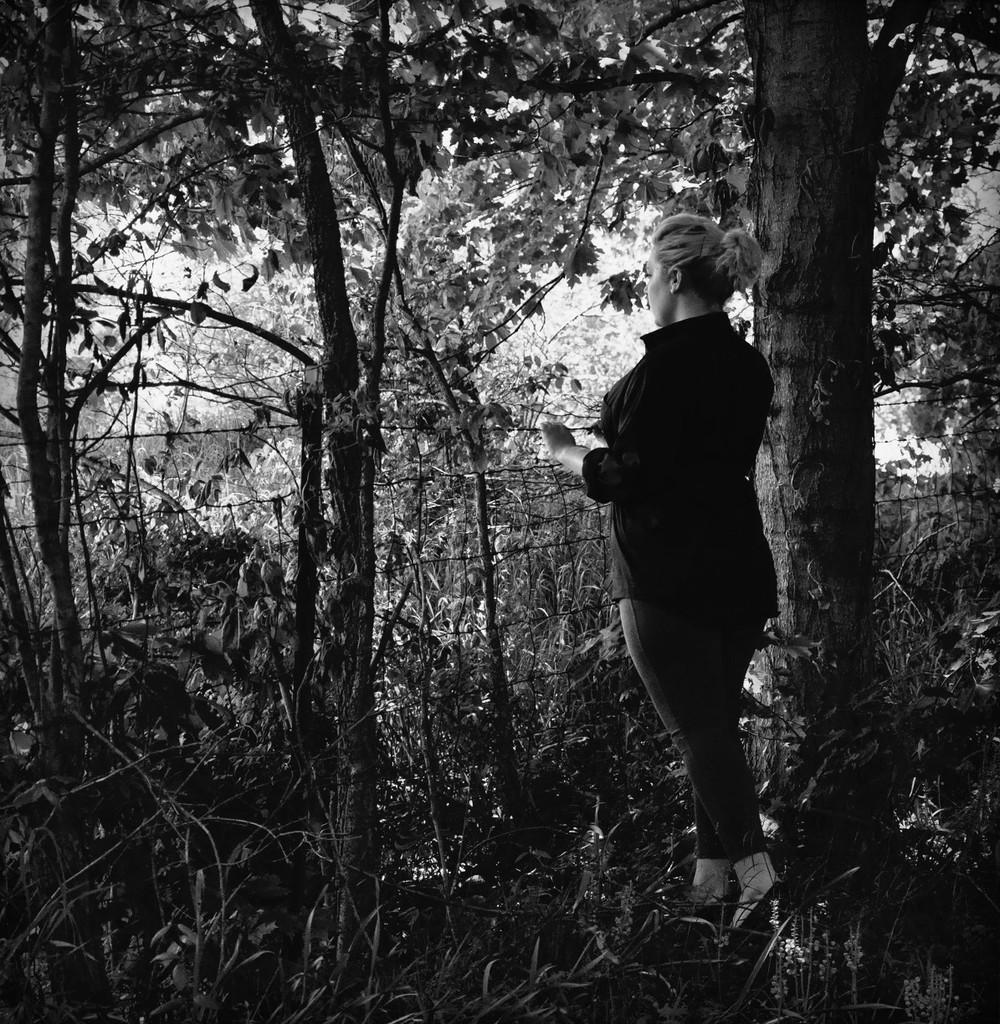What is the main subject of the image? There is a person standing in the image. What type of natural elements can be seen in the image? There are trees in the image. What type of structure is present in the image? There is fencing in the image. What color scheme is used in the image? The image is in black and white. What type of rice can be seen growing in the image? There is no rice present in the image; it features a person standing, trees, and fencing. How does the beam of sunlight affect the person in the image? There is no beam of sunlight present in the image, as it is in black and white. 